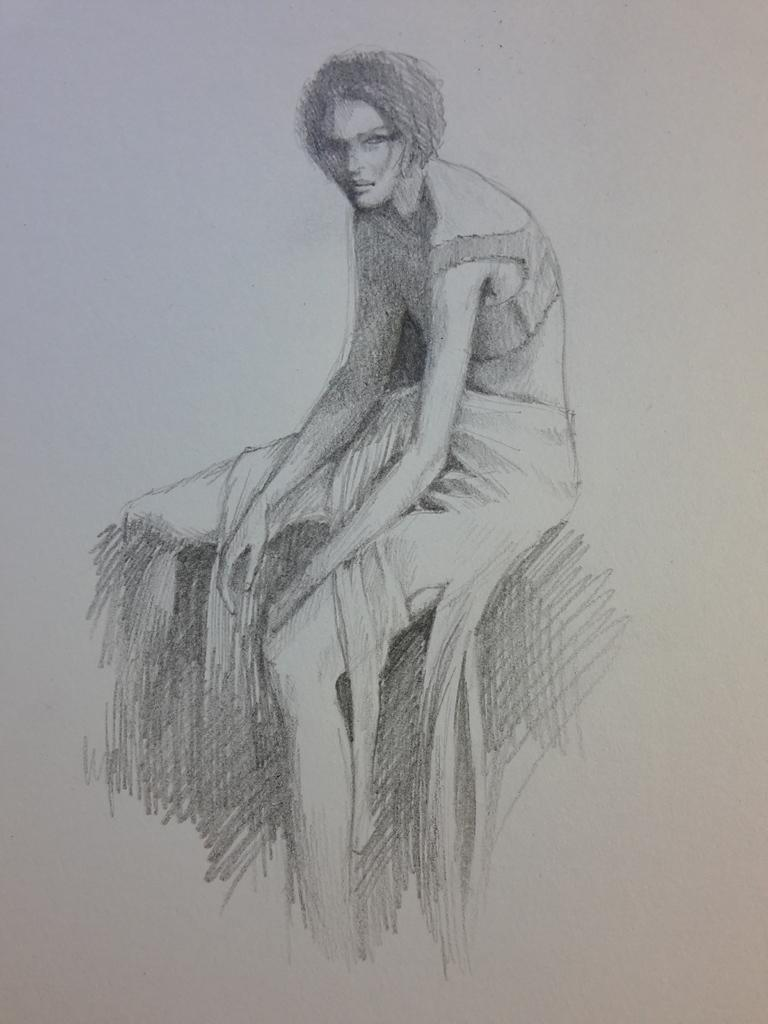What is the main subject of the image? There is a white object in the image. What is depicted on the white object? The white object has a sketch of a person on it. What are the colors of the sketch? The color of the sketch is black and white. How many chairs are visible in the image? There are no chairs visible in the image; it only features a white object with a sketch of a person. Is there a library in the background of the image? There is no library present in the image; it only features a white object with a sketch of a person. 